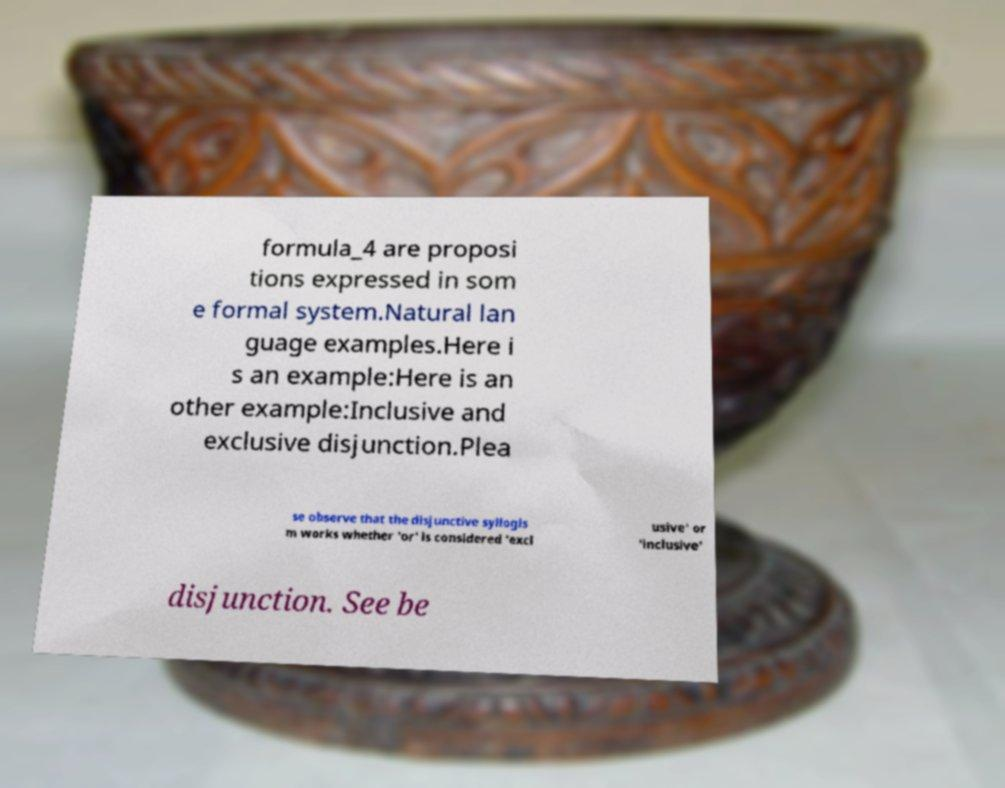Can you read and provide the text displayed in the image?This photo seems to have some interesting text. Can you extract and type it out for me? formula_4 are proposi tions expressed in som e formal system.Natural lan guage examples.Here i s an example:Here is an other example:Inclusive and exclusive disjunction.Plea se observe that the disjunctive syllogis m works whether 'or' is considered 'excl usive' or 'inclusive' disjunction. See be 